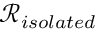<formula> <loc_0><loc_0><loc_500><loc_500>\mathcal { R } _ { i s o l a t e d }</formula> 